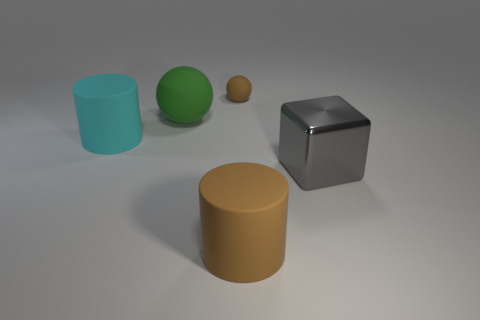How many brown rubber objects are behind the big cylinder to the right of the brown matte object that is behind the big metallic thing?
Provide a short and direct response. 1. There is a thing that is behind the large brown rubber object and in front of the cyan matte object; what material is it?
Your response must be concise. Metal. Does the brown cylinder have the same material as the large gray thing to the right of the big cyan rubber cylinder?
Your answer should be very brief. No. Are there more cylinders in front of the cyan rubber object than tiny rubber objects in front of the brown cylinder?
Keep it short and to the point. Yes. The cyan object is what shape?
Your answer should be compact. Cylinder. Is the ball that is behind the green object made of the same material as the cylinder behind the large metallic block?
Provide a succinct answer. Yes. What is the shape of the brown rubber thing that is behind the big gray shiny block?
Your answer should be compact. Sphere. What is the size of the other rubber thing that is the same shape as the green matte object?
Offer a very short reply. Small. Is there any other thing that is the same shape as the large gray thing?
Provide a succinct answer. No. Is there a brown ball that is behind the brown thing in front of the big ball?
Your answer should be very brief. Yes. 